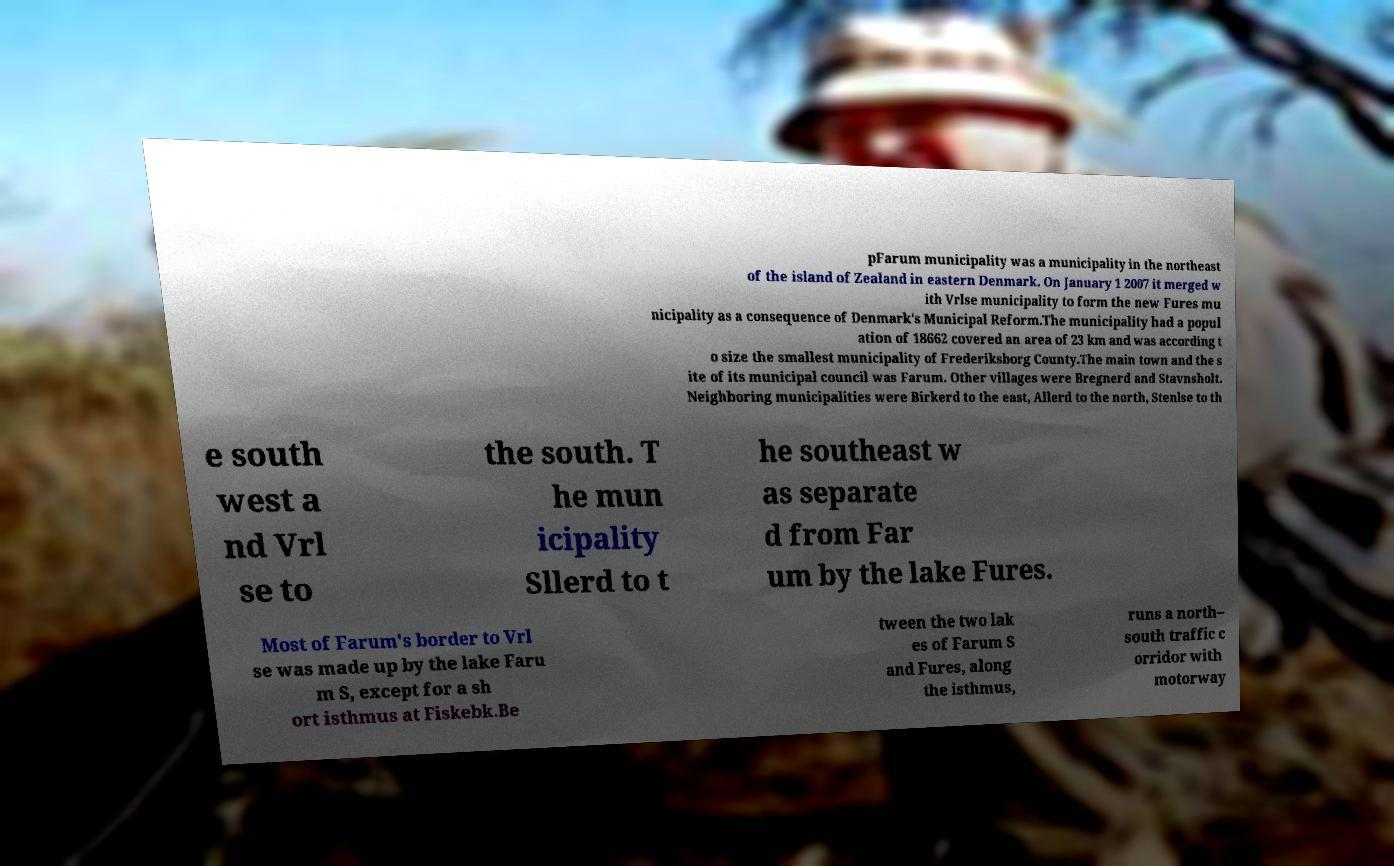Can you read and provide the text displayed in the image?This photo seems to have some interesting text. Can you extract and type it out for me? pFarum municipality was a municipality in the northeast of the island of Zealand in eastern Denmark. On January 1 2007 it merged w ith Vrlse municipality to form the new Fures mu nicipality as a consequence of Denmark's Municipal Reform.The municipality had a popul ation of 18662 covered an area of 23 km and was according t o size the smallest municipality of Frederiksborg County.The main town and the s ite of its municipal council was Farum. Other villages were Bregnerd and Stavnsholt. Neighboring municipalities were Birkerd to the east, Allerd to the north, Stenlse to th e south west a nd Vrl se to the south. T he mun icipality Sllerd to t he southeast w as separate d from Far um by the lake Fures. Most of Farum's border to Vrl se was made up by the lake Faru m S, except for a sh ort isthmus at Fiskebk.Be tween the two lak es of Farum S and Fures, along the isthmus, runs a north– south traffic c orridor with motorway 